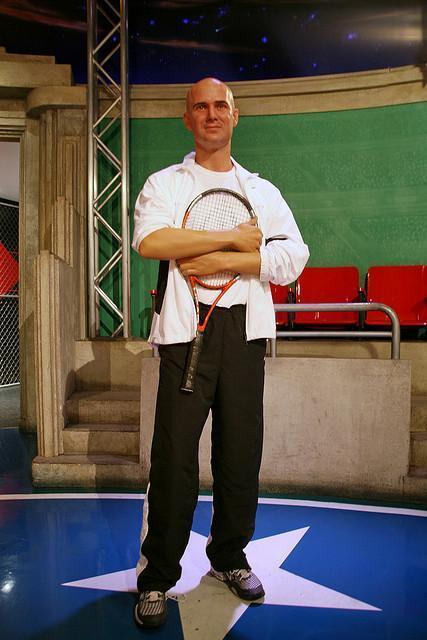How many chairs can be seen?
Give a very brief answer. 2. How many bikes are there?
Give a very brief answer. 0. 